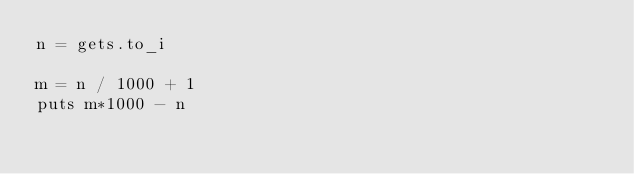Convert code to text. <code><loc_0><loc_0><loc_500><loc_500><_Ruby_>n = gets.to_i

m = n / 1000 + 1
puts m*1000 - n</code> 